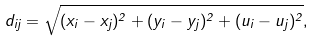<formula> <loc_0><loc_0><loc_500><loc_500>d _ { i j } = \sqrt { ( x _ { i } - x _ { j } ) ^ { 2 } + ( y _ { i } - y _ { j } ) ^ { 2 } + ( u _ { i } - u _ { j } ) ^ { 2 } } , \\</formula> 